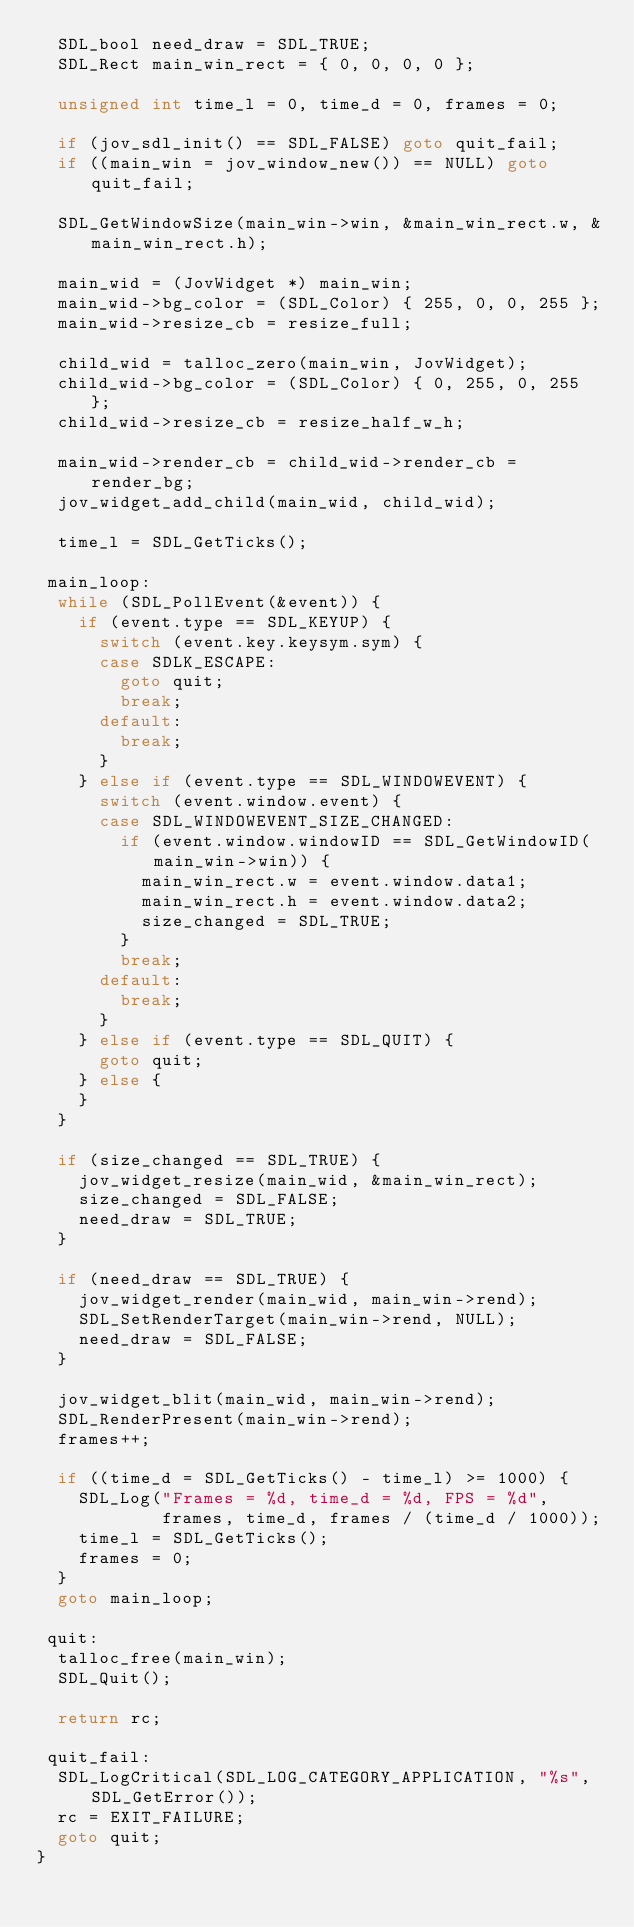Convert code to text. <code><loc_0><loc_0><loc_500><loc_500><_C_>  SDL_bool need_draw = SDL_TRUE;
  SDL_Rect main_win_rect = { 0, 0, 0, 0 };

  unsigned int time_l = 0, time_d = 0, frames = 0;

  if (jov_sdl_init() == SDL_FALSE) goto quit_fail;
  if ((main_win = jov_window_new()) == NULL) goto quit_fail;

  SDL_GetWindowSize(main_win->win, &main_win_rect.w, &main_win_rect.h);

  main_wid = (JovWidget *) main_win;
  main_wid->bg_color = (SDL_Color) { 255, 0, 0, 255 };
  main_wid->resize_cb = resize_full;

  child_wid = talloc_zero(main_win, JovWidget);
  child_wid->bg_color = (SDL_Color) { 0, 255, 0, 255 };
  child_wid->resize_cb = resize_half_w_h;

  main_wid->render_cb = child_wid->render_cb = render_bg;
  jov_widget_add_child(main_wid, child_wid);

  time_l = SDL_GetTicks();

 main_loop:
  while (SDL_PollEvent(&event)) {
    if (event.type == SDL_KEYUP) {
      switch (event.key.keysym.sym) {
      case SDLK_ESCAPE:
        goto quit;
        break;
      default:
        break;
      }
    } else if (event.type == SDL_WINDOWEVENT) {
      switch (event.window.event) {
      case SDL_WINDOWEVENT_SIZE_CHANGED:
        if (event.window.windowID == SDL_GetWindowID(main_win->win)) {
          main_win_rect.w = event.window.data1;
          main_win_rect.h = event.window.data2;
          size_changed = SDL_TRUE;
        }
        break;
      default:
        break;
      }
    } else if (event.type == SDL_QUIT) {
      goto quit;
    } else {
    }
  }

  if (size_changed == SDL_TRUE) {
    jov_widget_resize(main_wid, &main_win_rect);
    size_changed = SDL_FALSE;
    need_draw = SDL_TRUE;
  }

  if (need_draw == SDL_TRUE) {
    jov_widget_render(main_wid, main_win->rend);
    SDL_SetRenderTarget(main_win->rend, NULL);
    need_draw = SDL_FALSE;
  }

  jov_widget_blit(main_wid, main_win->rend);
  SDL_RenderPresent(main_win->rend);
  frames++;

  if ((time_d = SDL_GetTicks() - time_l) >= 1000) {
    SDL_Log("Frames = %d, time_d = %d, FPS = %d",
            frames, time_d, frames / (time_d / 1000));
    time_l = SDL_GetTicks();
    frames = 0;
  }
  goto main_loop;

 quit:
  talloc_free(main_win);
  SDL_Quit();

  return rc;

 quit_fail:
  SDL_LogCritical(SDL_LOG_CATEGORY_APPLICATION, "%s", SDL_GetError());
  rc = EXIT_FAILURE;
  goto quit;
}
</code> 